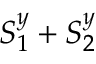<formula> <loc_0><loc_0><loc_500><loc_500>S _ { 1 } ^ { y } + S _ { 2 } ^ { y }</formula> 